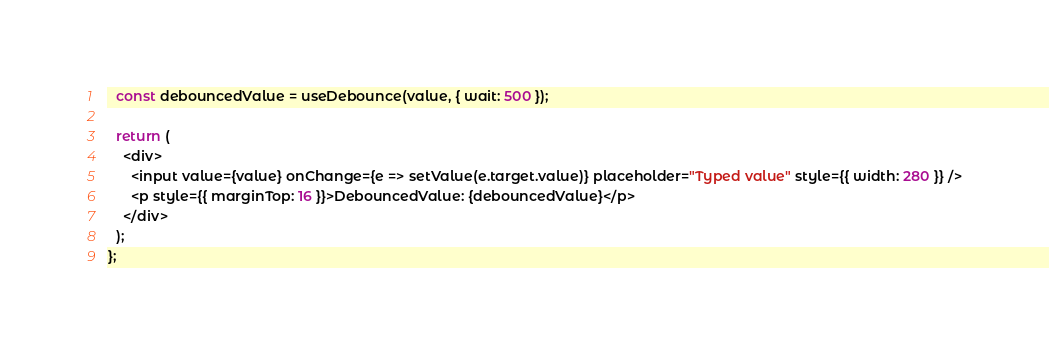Convert code to text. <code><loc_0><loc_0><loc_500><loc_500><_TypeScript_>  const debouncedValue = useDebounce(value, { wait: 500 });

  return (
    <div>
      <input value={value} onChange={e => setValue(e.target.value)} placeholder="Typed value" style={{ width: 280 }} />
      <p style={{ marginTop: 16 }}>DebouncedValue: {debouncedValue}</p>
    </div>
  );
};
</code> 